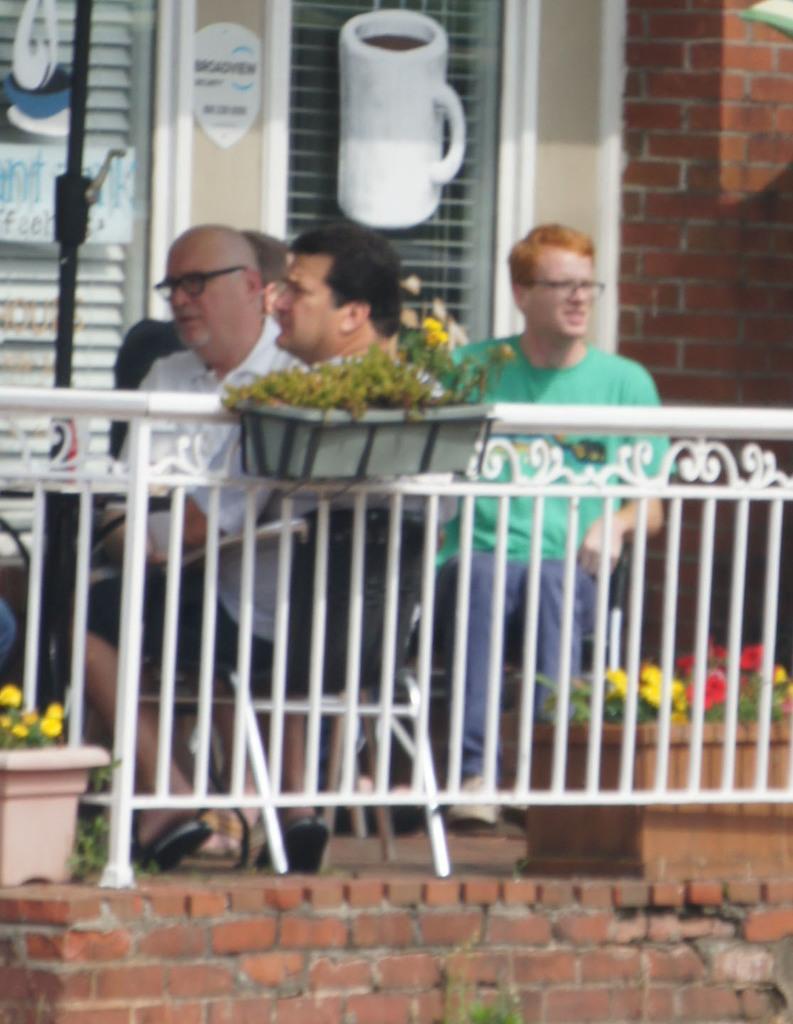Could you give a brief overview of what you see in this image? In this image there are persons sitting in the center. In the front there is a fence which is white in colour and there is a flower pot hanging on the fence. There is a wall and in the background there is a door. 